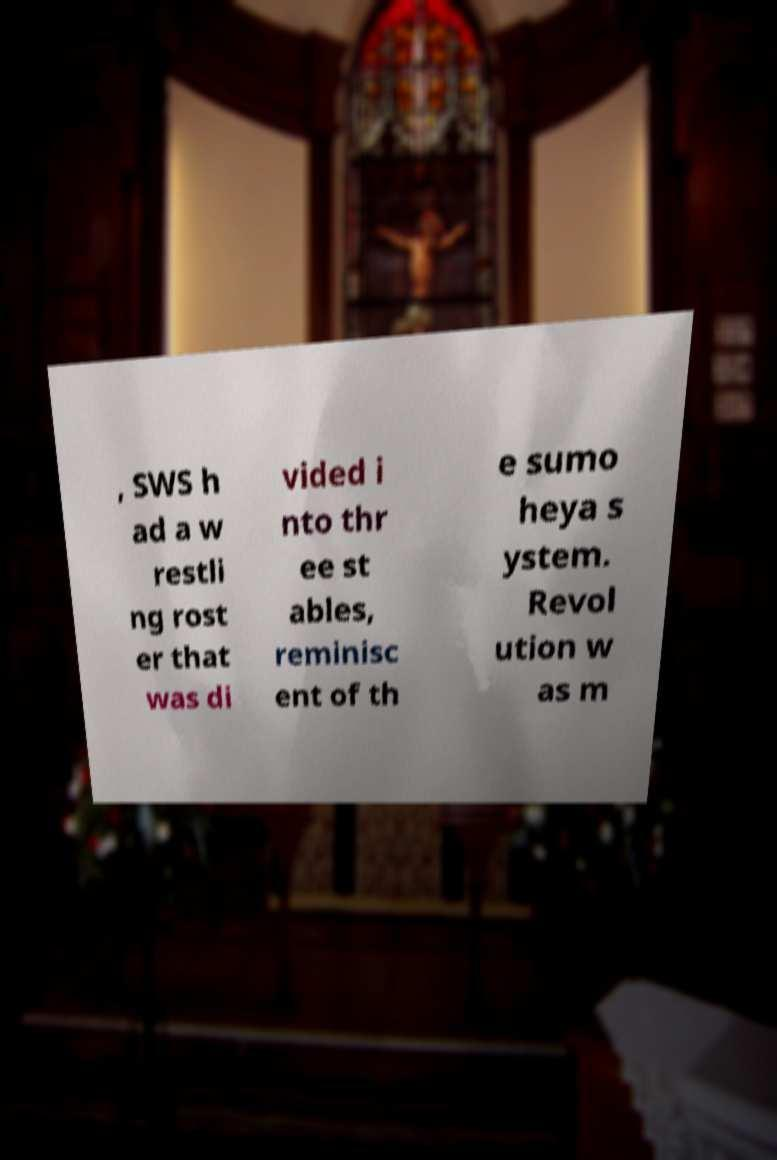Could you extract and type out the text from this image? , SWS h ad a w restli ng rost er that was di vided i nto thr ee st ables, reminisc ent of th e sumo heya s ystem. Revol ution w as m 